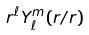<formula> <loc_0><loc_0><loc_500><loc_500>r ^ { \ell } Y _ { \ell } ^ { m } ( r / r )</formula> 